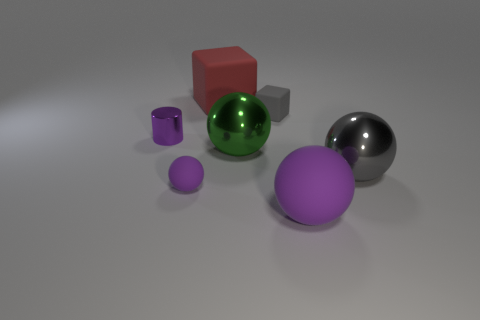Could you infer the material of the green sphere due to its appearance? The green sphere has a highly reflective, shiny surface, which may indicate that it's made of a polished material like glass or a smooth, reflective plastic. Its gleaming facade stands out distinctly from the matte finishes of the other objects, suggesting a different composition or treatment. 